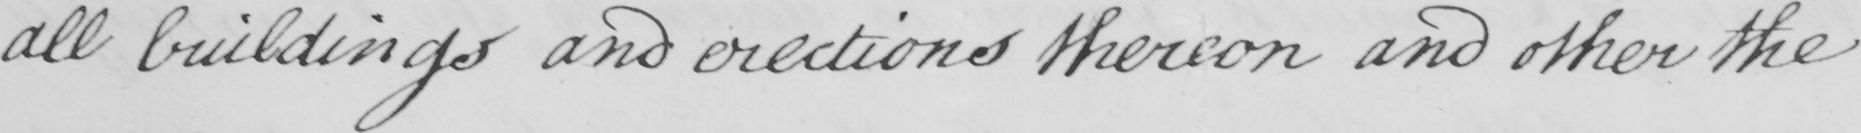What text is written in this handwritten line? all buildings and erections thereon and other the 